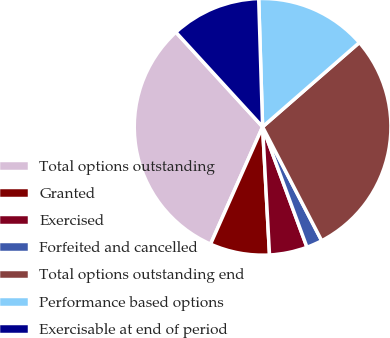Convert chart. <chart><loc_0><loc_0><loc_500><loc_500><pie_chart><fcel>Total options outstanding<fcel>Granted<fcel>Exercised<fcel>Forfeited and cancelled<fcel>Total options outstanding end<fcel>Performance based options<fcel>Exercisable at end of period<nl><fcel>31.55%<fcel>7.51%<fcel>4.76%<fcel>2.0%<fcel>28.79%<fcel>14.08%<fcel>11.32%<nl></chart> 